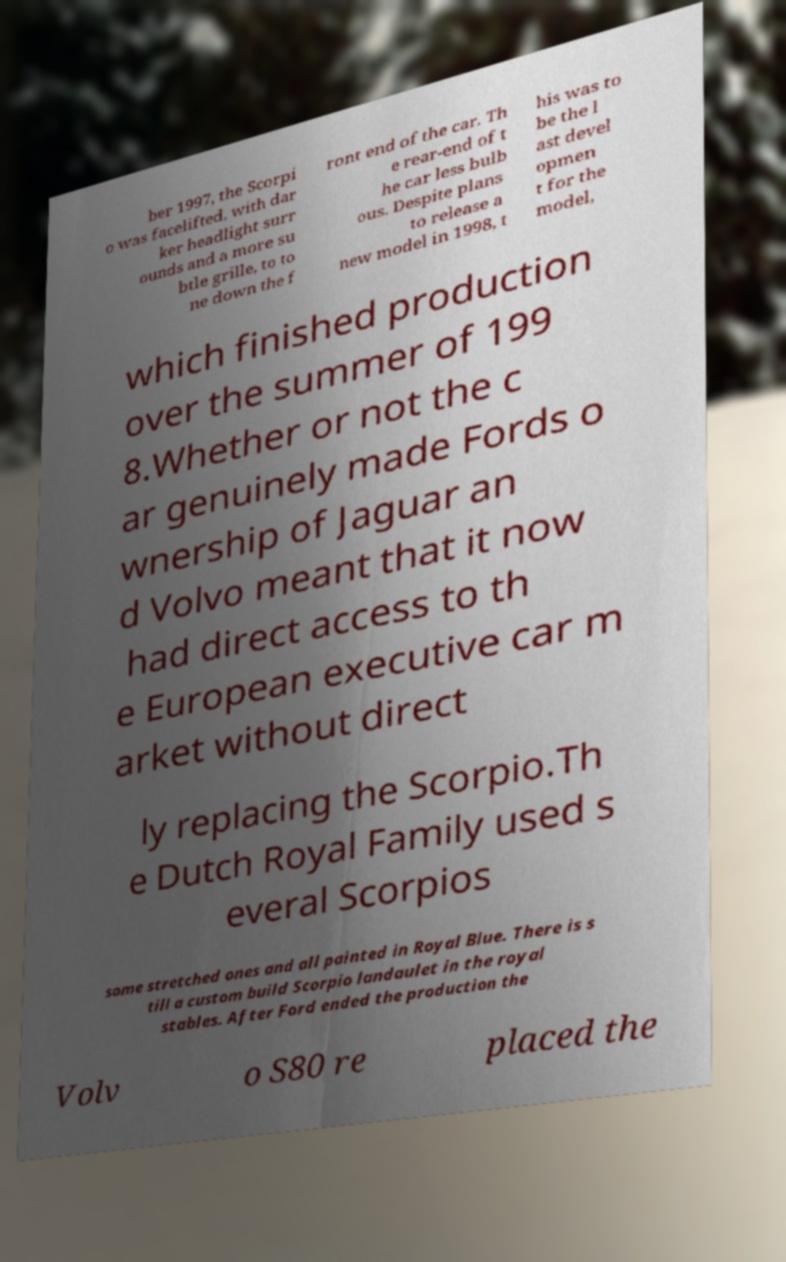Can you accurately transcribe the text from the provided image for me? ber 1997, the Scorpi o was facelifted, with dar ker headlight surr ounds and a more su btle grille, to to ne down the f ront end of the car. Th e rear-end of t he car less bulb ous. Despite plans to release a new model in 1998, t his was to be the l ast devel opmen t for the model, which finished production over the summer of 199 8.Whether or not the c ar genuinely made Fords o wnership of Jaguar an d Volvo meant that it now had direct access to th e European executive car m arket without direct ly replacing the Scorpio.Th e Dutch Royal Family used s everal Scorpios some stretched ones and all painted in Royal Blue. There is s till a custom build Scorpio landaulet in the royal stables. After Ford ended the production the Volv o S80 re placed the 